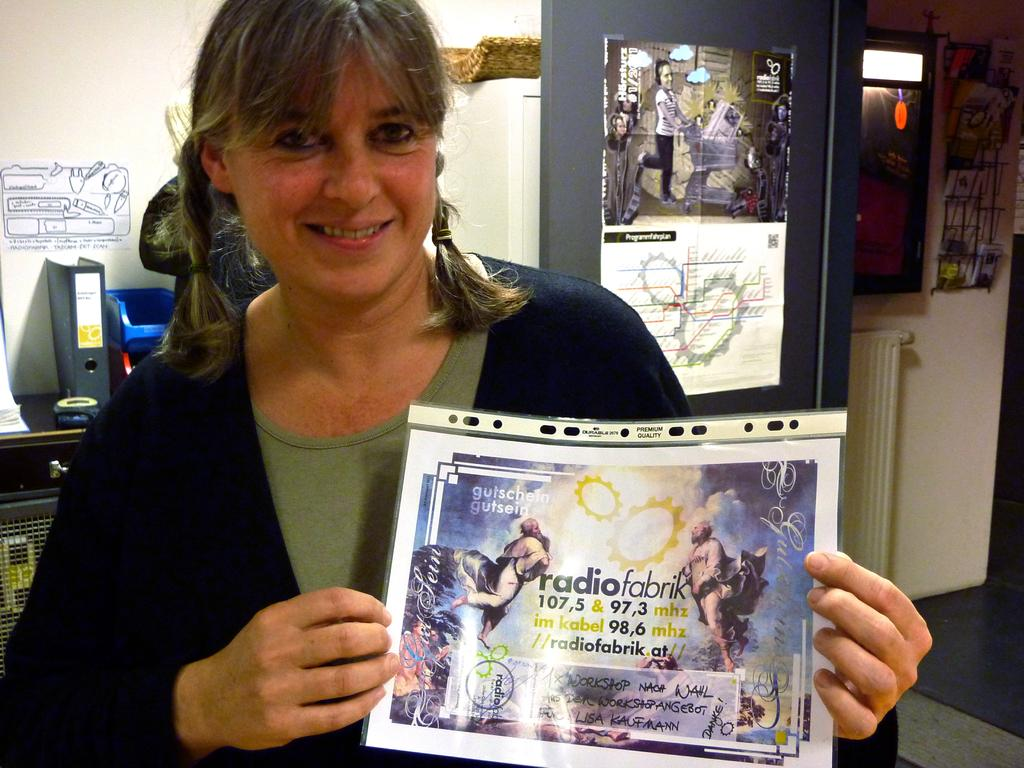Provide a one-sentence caption for the provided image. A woman holds a flyer for RadioFabrik in a plastic sleeve. 